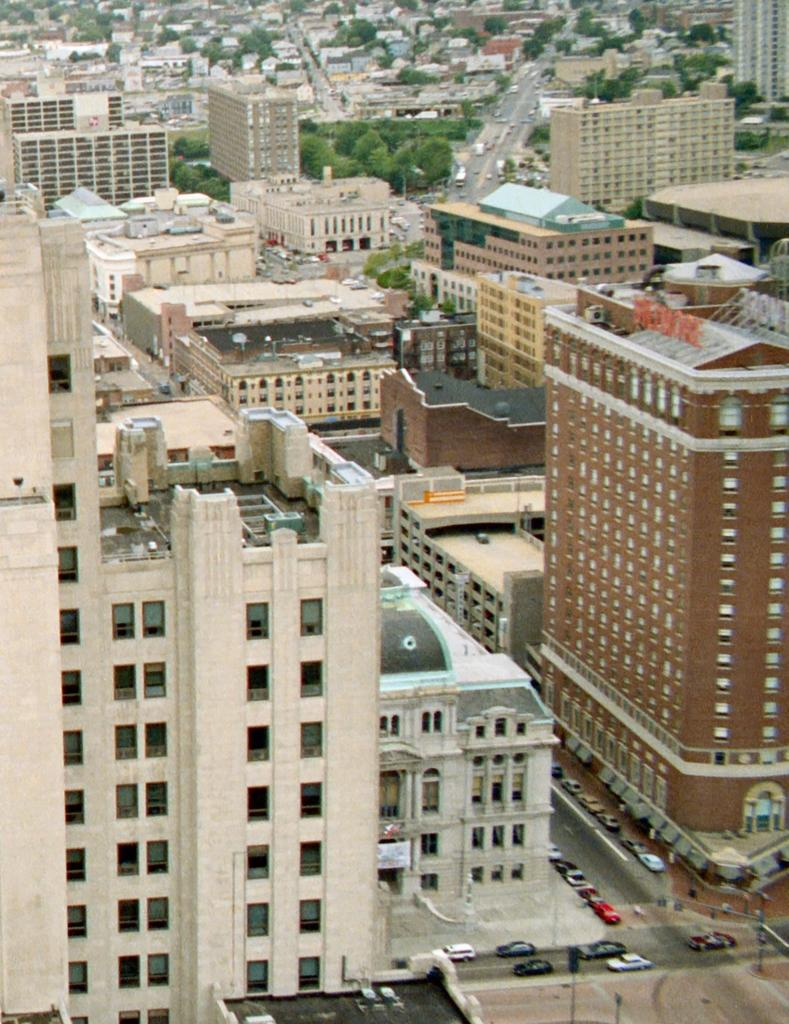What types of structures are present in the image? There are buildings and houses in the image. What other elements can be seen in the image besides structures? There are trees and light poles in the image. What mode of transportation is visible in the image? There are fleets of vehicles on the road in the image. What feature is common to many of the structures in the image? There are windows visible in the image. What time of day is the image likely taken? The image is likely taken during the day, as there is sufficient light to see the details. What type of stem can be seen growing from the floor in the image? There is no stem or floor present in the image; it features buildings, houses, trees, light poles, vehicles, and windows. What type of pump is visible in the image? There is no pump present in the image. 